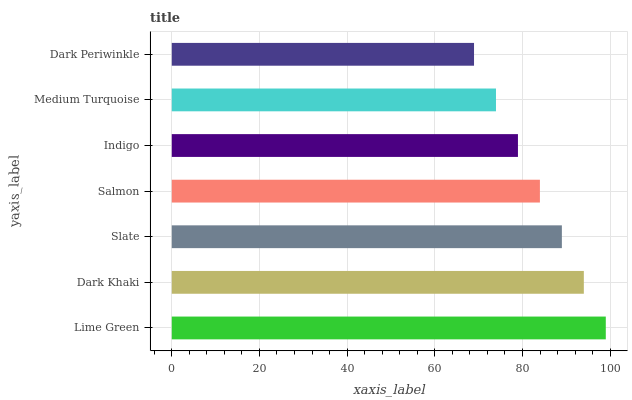Is Dark Periwinkle the minimum?
Answer yes or no. Yes. Is Lime Green the maximum?
Answer yes or no. Yes. Is Dark Khaki the minimum?
Answer yes or no. No. Is Dark Khaki the maximum?
Answer yes or no. No. Is Lime Green greater than Dark Khaki?
Answer yes or no. Yes. Is Dark Khaki less than Lime Green?
Answer yes or no. Yes. Is Dark Khaki greater than Lime Green?
Answer yes or no. No. Is Lime Green less than Dark Khaki?
Answer yes or no. No. Is Salmon the high median?
Answer yes or no. Yes. Is Salmon the low median?
Answer yes or no. Yes. Is Indigo the high median?
Answer yes or no. No. Is Medium Turquoise the low median?
Answer yes or no. No. 